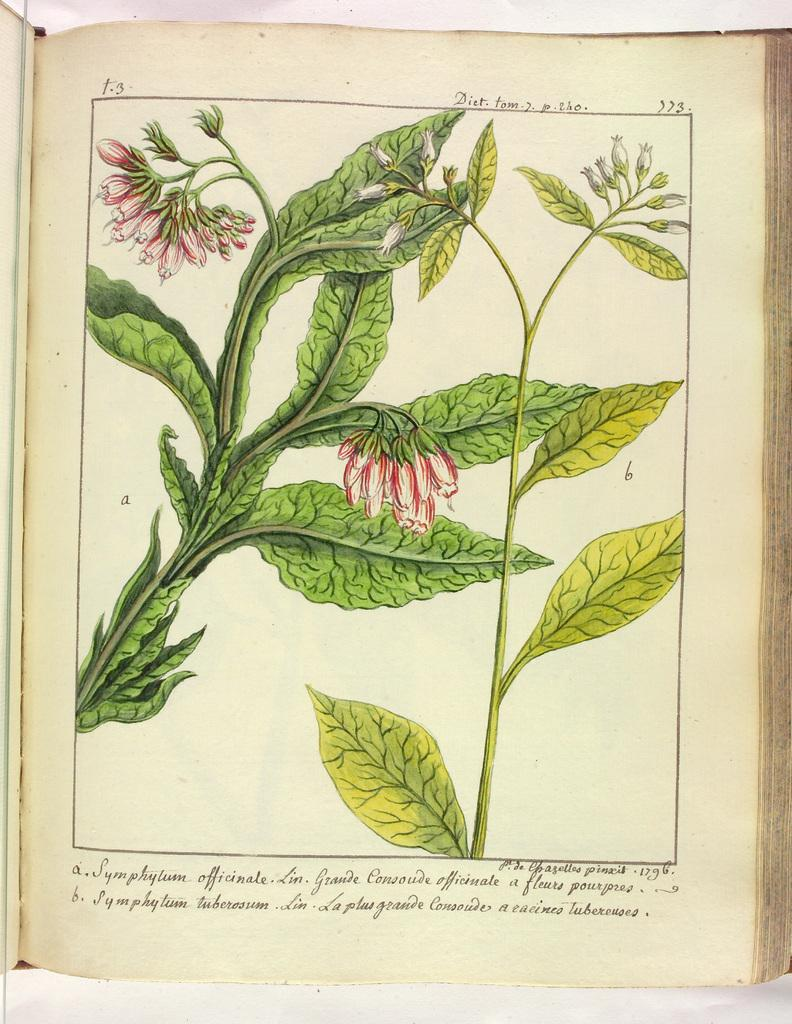What is present in the image related to reading material? There is a book in the image. Can you describe the state of the book in the image? The book has a page open. What can be seen on the open page of the book? The open page contains an illustration of leaves and flowers. Is there any text on the open page? Yes, there is text on the open page. What type of music is the band playing in the image? There is no band present in the image, so it is not possible to determine what type of music they might be playing. 